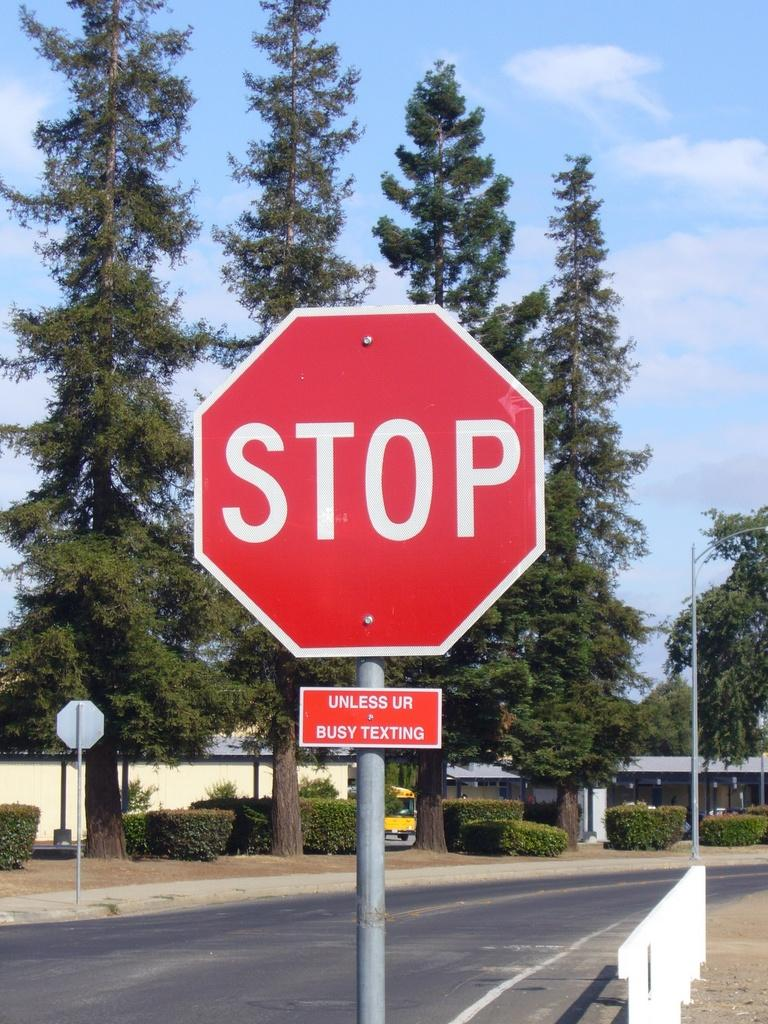<image>
Share a concise interpretation of the image provided. A smaller sign is under a stop sign, which reads "unless ur busy texting." 